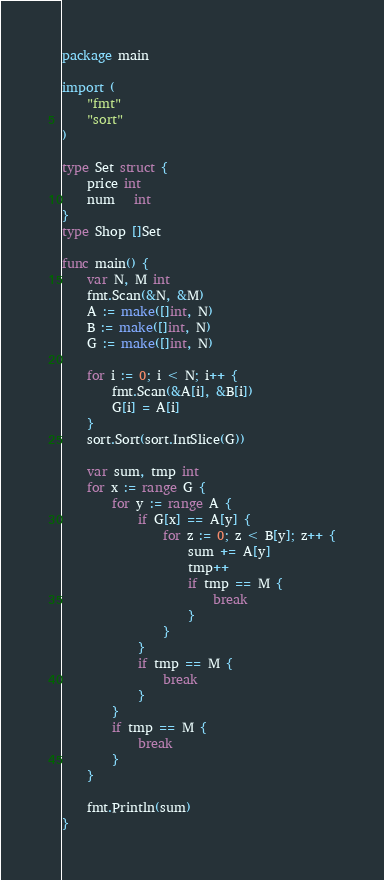<code> <loc_0><loc_0><loc_500><loc_500><_Go_>package main

import (
	"fmt"
	"sort"
)

type Set struct {
	price int
	num   int
}
type Shop []Set

func main() {
	var N, M int
	fmt.Scan(&N, &M)
	A := make([]int, N)
	B := make([]int, N)
	G := make([]int, N)

	for i := 0; i < N; i++ {
		fmt.Scan(&A[i], &B[i])
		G[i] = A[i]
	}
	sort.Sort(sort.IntSlice(G))

	var sum, tmp int
	for x := range G {
		for y := range A {
			if G[x] == A[y] {
				for z := 0; z < B[y]; z++ {
					sum += A[y]
					tmp++
					if tmp == M {
						break
					}
				}
			}
			if tmp == M {
				break
			}
		}
		if tmp == M {
			break
		}
	}

	fmt.Println(sum)
}
</code> 